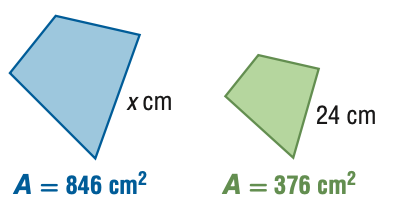Answer the mathemtical geometry problem and directly provide the correct option letter.
Question: For the pair of similar figures, use the given areas to find the scale factor of the blue to the green figure.
Choices: A: \frac { 4 } { 9 } B: \frac { 2 } { 3 } C: \frac { 3 } { 2 } D: \frac { 9 } { 4 } C 